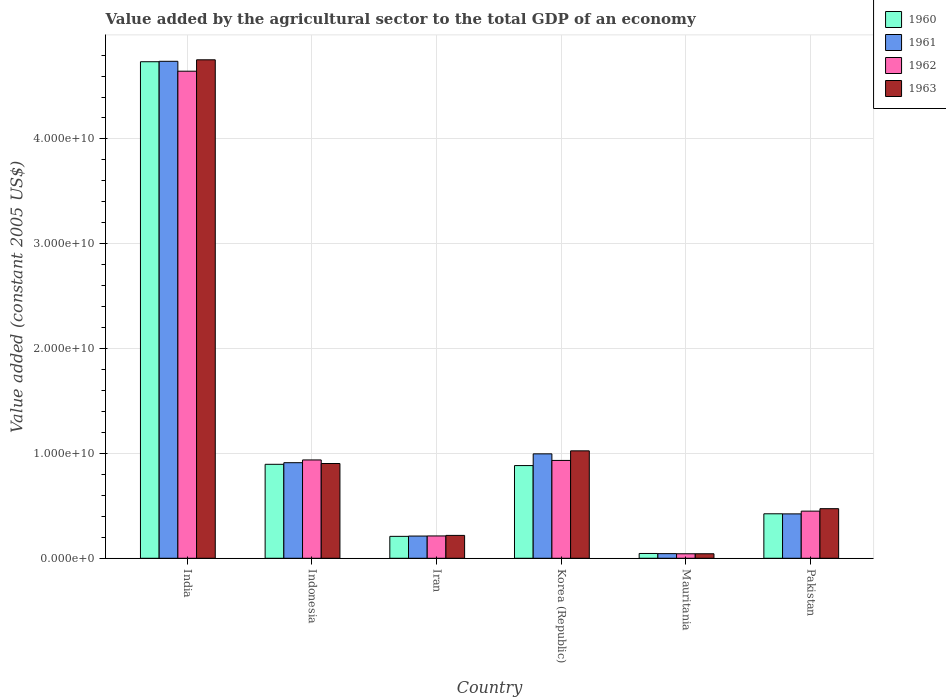Are the number of bars per tick equal to the number of legend labels?
Offer a very short reply. Yes. How many bars are there on the 5th tick from the left?
Give a very brief answer. 4. How many bars are there on the 6th tick from the right?
Make the answer very short. 4. What is the label of the 5th group of bars from the left?
Keep it short and to the point. Mauritania. In how many cases, is the number of bars for a given country not equal to the number of legend labels?
Your answer should be compact. 0. What is the value added by the agricultural sector in 1960 in Indonesia?
Make the answer very short. 8.96e+09. Across all countries, what is the maximum value added by the agricultural sector in 1961?
Give a very brief answer. 4.74e+1. Across all countries, what is the minimum value added by the agricultural sector in 1960?
Provide a succinct answer. 4.57e+08. In which country was the value added by the agricultural sector in 1960 maximum?
Provide a succinct answer. India. In which country was the value added by the agricultural sector in 1962 minimum?
Ensure brevity in your answer.  Mauritania. What is the total value added by the agricultural sector in 1962 in the graph?
Offer a very short reply. 7.22e+1. What is the difference between the value added by the agricultural sector in 1963 in Mauritania and that in Pakistan?
Your answer should be compact. -4.30e+09. What is the difference between the value added by the agricultural sector in 1961 in Pakistan and the value added by the agricultural sector in 1962 in India?
Your answer should be very brief. -4.22e+1. What is the average value added by the agricultural sector in 1963 per country?
Offer a terse response. 1.24e+1. What is the difference between the value added by the agricultural sector of/in 1962 and value added by the agricultural sector of/in 1960 in India?
Offer a very short reply. -9.03e+08. In how many countries, is the value added by the agricultural sector in 1960 greater than 6000000000 US$?
Ensure brevity in your answer.  3. What is the ratio of the value added by the agricultural sector in 1962 in Korea (Republic) to that in Mauritania?
Provide a short and direct response. 21.75. Is the value added by the agricultural sector in 1961 in Indonesia less than that in Pakistan?
Your answer should be compact. No. Is the difference between the value added by the agricultural sector in 1962 in Iran and Pakistan greater than the difference between the value added by the agricultural sector in 1960 in Iran and Pakistan?
Provide a short and direct response. No. What is the difference between the highest and the second highest value added by the agricultural sector in 1962?
Your response must be concise. 3.71e+1. What is the difference between the highest and the lowest value added by the agricultural sector in 1963?
Keep it short and to the point. 4.71e+1. Is the sum of the value added by the agricultural sector in 1962 in Korea (Republic) and Mauritania greater than the maximum value added by the agricultural sector in 1963 across all countries?
Provide a succinct answer. No. What does the 3rd bar from the left in India represents?
Make the answer very short. 1962. What does the 2nd bar from the right in Iran represents?
Make the answer very short. 1962. Are all the bars in the graph horizontal?
Ensure brevity in your answer.  No. How many countries are there in the graph?
Keep it short and to the point. 6. Are the values on the major ticks of Y-axis written in scientific E-notation?
Provide a succinct answer. Yes. How many legend labels are there?
Keep it short and to the point. 4. What is the title of the graph?
Your response must be concise. Value added by the agricultural sector to the total GDP of an economy. Does "1988" appear as one of the legend labels in the graph?
Provide a short and direct response. No. What is the label or title of the Y-axis?
Your answer should be very brief. Value added (constant 2005 US$). What is the Value added (constant 2005 US$) of 1960 in India?
Ensure brevity in your answer.  4.74e+1. What is the Value added (constant 2005 US$) of 1961 in India?
Offer a terse response. 4.74e+1. What is the Value added (constant 2005 US$) of 1962 in India?
Ensure brevity in your answer.  4.65e+1. What is the Value added (constant 2005 US$) of 1963 in India?
Your response must be concise. 4.76e+1. What is the Value added (constant 2005 US$) in 1960 in Indonesia?
Keep it short and to the point. 8.96e+09. What is the Value added (constant 2005 US$) in 1961 in Indonesia?
Your answer should be very brief. 9.12e+09. What is the Value added (constant 2005 US$) of 1962 in Indonesia?
Keep it short and to the point. 9.38e+09. What is the Value added (constant 2005 US$) of 1963 in Indonesia?
Your response must be concise. 9.04e+09. What is the Value added (constant 2005 US$) of 1960 in Iran?
Your response must be concise. 2.09e+09. What is the Value added (constant 2005 US$) of 1961 in Iran?
Provide a short and direct response. 2.12e+09. What is the Value added (constant 2005 US$) of 1962 in Iran?
Provide a succinct answer. 2.13e+09. What is the Value added (constant 2005 US$) of 1963 in Iran?
Your response must be concise. 2.18e+09. What is the Value added (constant 2005 US$) in 1960 in Korea (Republic)?
Your answer should be compact. 8.84e+09. What is the Value added (constant 2005 US$) of 1961 in Korea (Republic)?
Give a very brief answer. 9.96e+09. What is the Value added (constant 2005 US$) in 1962 in Korea (Republic)?
Provide a succinct answer. 9.33e+09. What is the Value added (constant 2005 US$) of 1963 in Korea (Republic)?
Provide a succinct answer. 1.02e+1. What is the Value added (constant 2005 US$) in 1960 in Mauritania?
Your answer should be compact. 4.57e+08. What is the Value added (constant 2005 US$) in 1961 in Mauritania?
Your response must be concise. 4.42e+08. What is the Value added (constant 2005 US$) of 1962 in Mauritania?
Keep it short and to the point. 4.29e+08. What is the Value added (constant 2005 US$) in 1963 in Mauritania?
Make the answer very short. 4.30e+08. What is the Value added (constant 2005 US$) of 1960 in Pakistan?
Offer a very short reply. 4.24e+09. What is the Value added (constant 2005 US$) in 1961 in Pakistan?
Make the answer very short. 4.23e+09. What is the Value added (constant 2005 US$) in 1962 in Pakistan?
Your response must be concise. 4.50e+09. What is the Value added (constant 2005 US$) in 1963 in Pakistan?
Your response must be concise. 4.73e+09. Across all countries, what is the maximum Value added (constant 2005 US$) of 1960?
Give a very brief answer. 4.74e+1. Across all countries, what is the maximum Value added (constant 2005 US$) in 1961?
Your answer should be very brief. 4.74e+1. Across all countries, what is the maximum Value added (constant 2005 US$) in 1962?
Provide a succinct answer. 4.65e+1. Across all countries, what is the maximum Value added (constant 2005 US$) in 1963?
Offer a terse response. 4.76e+1. Across all countries, what is the minimum Value added (constant 2005 US$) in 1960?
Provide a short and direct response. 4.57e+08. Across all countries, what is the minimum Value added (constant 2005 US$) of 1961?
Provide a short and direct response. 4.42e+08. Across all countries, what is the minimum Value added (constant 2005 US$) of 1962?
Ensure brevity in your answer.  4.29e+08. Across all countries, what is the minimum Value added (constant 2005 US$) in 1963?
Give a very brief answer. 4.30e+08. What is the total Value added (constant 2005 US$) of 1960 in the graph?
Ensure brevity in your answer.  7.20e+1. What is the total Value added (constant 2005 US$) in 1961 in the graph?
Offer a very short reply. 7.33e+1. What is the total Value added (constant 2005 US$) in 1962 in the graph?
Your response must be concise. 7.22e+1. What is the total Value added (constant 2005 US$) of 1963 in the graph?
Your response must be concise. 7.42e+1. What is the difference between the Value added (constant 2005 US$) in 1960 in India and that in Indonesia?
Your answer should be compact. 3.84e+1. What is the difference between the Value added (constant 2005 US$) of 1961 in India and that in Indonesia?
Give a very brief answer. 3.83e+1. What is the difference between the Value added (constant 2005 US$) of 1962 in India and that in Indonesia?
Your answer should be compact. 3.71e+1. What is the difference between the Value added (constant 2005 US$) in 1963 in India and that in Indonesia?
Your response must be concise. 3.85e+1. What is the difference between the Value added (constant 2005 US$) of 1960 in India and that in Iran?
Make the answer very short. 4.53e+1. What is the difference between the Value added (constant 2005 US$) of 1961 in India and that in Iran?
Offer a terse response. 4.53e+1. What is the difference between the Value added (constant 2005 US$) in 1962 in India and that in Iran?
Provide a succinct answer. 4.43e+1. What is the difference between the Value added (constant 2005 US$) in 1963 in India and that in Iran?
Your answer should be compact. 4.54e+1. What is the difference between the Value added (constant 2005 US$) of 1960 in India and that in Korea (Republic)?
Provide a short and direct response. 3.85e+1. What is the difference between the Value added (constant 2005 US$) in 1961 in India and that in Korea (Republic)?
Your response must be concise. 3.74e+1. What is the difference between the Value added (constant 2005 US$) in 1962 in India and that in Korea (Republic)?
Offer a terse response. 3.71e+1. What is the difference between the Value added (constant 2005 US$) of 1963 in India and that in Korea (Republic)?
Offer a terse response. 3.73e+1. What is the difference between the Value added (constant 2005 US$) of 1960 in India and that in Mauritania?
Offer a very short reply. 4.69e+1. What is the difference between the Value added (constant 2005 US$) in 1961 in India and that in Mauritania?
Give a very brief answer. 4.70e+1. What is the difference between the Value added (constant 2005 US$) of 1962 in India and that in Mauritania?
Your response must be concise. 4.60e+1. What is the difference between the Value added (constant 2005 US$) of 1963 in India and that in Mauritania?
Keep it short and to the point. 4.71e+1. What is the difference between the Value added (constant 2005 US$) of 1960 in India and that in Pakistan?
Provide a short and direct response. 4.31e+1. What is the difference between the Value added (constant 2005 US$) in 1961 in India and that in Pakistan?
Your answer should be compact. 4.32e+1. What is the difference between the Value added (constant 2005 US$) of 1962 in India and that in Pakistan?
Your response must be concise. 4.20e+1. What is the difference between the Value added (constant 2005 US$) of 1963 in India and that in Pakistan?
Provide a short and direct response. 4.28e+1. What is the difference between the Value added (constant 2005 US$) in 1960 in Indonesia and that in Iran?
Your answer should be very brief. 6.87e+09. What is the difference between the Value added (constant 2005 US$) in 1961 in Indonesia and that in Iran?
Offer a very short reply. 7.00e+09. What is the difference between the Value added (constant 2005 US$) of 1962 in Indonesia and that in Iran?
Give a very brief answer. 7.25e+09. What is the difference between the Value added (constant 2005 US$) in 1963 in Indonesia and that in Iran?
Make the answer very short. 6.86e+09. What is the difference between the Value added (constant 2005 US$) of 1960 in Indonesia and that in Korea (Republic)?
Make the answer very short. 1.19e+08. What is the difference between the Value added (constant 2005 US$) of 1961 in Indonesia and that in Korea (Republic)?
Provide a succinct answer. -8.44e+08. What is the difference between the Value added (constant 2005 US$) of 1962 in Indonesia and that in Korea (Republic)?
Provide a short and direct response. 4.52e+07. What is the difference between the Value added (constant 2005 US$) of 1963 in Indonesia and that in Korea (Republic)?
Your answer should be compact. -1.21e+09. What is the difference between the Value added (constant 2005 US$) of 1960 in Indonesia and that in Mauritania?
Ensure brevity in your answer.  8.51e+09. What is the difference between the Value added (constant 2005 US$) in 1961 in Indonesia and that in Mauritania?
Your response must be concise. 8.68e+09. What is the difference between the Value added (constant 2005 US$) of 1962 in Indonesia and that in Mauritania?
Your answer should be compact. 8.95e+09. What is the difference between the Value added (constant 2005 US$) in 1963 in Indonesia and that in Mauritania?
Ensure brevity in your answer.  8.61e+09. What is the difference between the Value added (constant 2005 US$) of 1960 in Indonesia and that in Pakistan?
Your answer should be very brief. 4.72e+09. What is the difference between the Value added (constant 2005 US$) of 1961 in Indonesia and that in Pakistan?
Provide a short and direct response. 4.88e+09. What is the difference between the Value added (constant 2005 US$) of 1962 in Indonesia and that in Pakistan?
Make the answer very short. 4.88e+09. What is the difference between the Value added (constant 2005 US$) in 1963 in Indonesia and that in Pakistan?
Offer a very short reply. 4.31e+09. What is the difference between the Value added (constant 2005 US$) of 1960 in Iran and that in Korea (Republic)?
Offer a terse response. -6.75e+09. What is the difference between the Value added (constant 2005 US$) in 1961 in Iran and that in Korea (Republic)?
Provide a succinct answer. -7.84e+09. What is the difference between the Value added (constant 2005 US$) in 1962 in Iran and that in Korea (Republic)?
Ensure brevity in your answer.  -7.20e+09. What is the difference between the Value added (constant 2005 US$) in 1963 in Iran and that in Korea (Republic)?
Offer a very short reply. -8.07e+09. What is the difference between the Value added (constant 2005 US$) in 1960 in Iran and that in Mauritania?
Provide a succinct answer. 1.63e+09. What is the difference between the Value added (constant 2005 US$) in 1961 in Iran and that in Mauritania?
Provide a short and direct response. 1.68e+09. What is the difference between the Value added (constant 2005 US$) in 1962 in Iran and that in Mauritania?
Keep it short and to the point. 1.70e+09. What is the difference between the Value added (constant 2005 US$) of 1963 in Iran and that in Mauritania?
Your answer should be very brief. 1.75e+09. What is the difference between the Value added (constant 2005 US$) in 1960 in Iran and that in Pakistan?
Offer a very short reply. -2.15e+09. What is the difference between the Value added (constant 2005 US$) in 1961 in Iran and that in Pakistan?
Ensure brevity in your answer.  -2.11e+09. What is the difference between the Value added (constant 2005 US$) in 1962 in Iran and that in Pakistan?
Your answer should be compact. -2.37e+09. What is the difference between the Value added (constant 2005 US$) of 1963 in Iran and that in Pakistan?
Give a very brief answer. -2.55e+09. What is the difference between the Value added (constant 2005 US$) of 1960 in Korea (Republic) and that in Mauritania?
Provide a succinct answer. 8.39e+09. What is the difference between the Value added (constant 2005 US$) in 1961 in Korea (Republic) and that in Mauritania?
Give a very brief answer. 9.52e+09. What is the difference between the Value added (constant 2005 US$) in 1962 in Korea (Republic) and that in Mauritania?
Your response must be concise. 8.91e+09. What is the difference between the Value added (constant 2005 US$) in 1963 in Korea (Republic) and that in Mauritania?
Keep it short and to the point. 9.82e+09. What is the difference between the Value added (constant 2005 US$) of 1960 in Korea (Republic) and that in Pakistan?
Offer a very short reply. 4.60e+09. What is the difference between the Value added (constant 2005 US$) of 1961 in Korea (Republic) and that in Pakistan?
Your answer should be compact. 5.73e+09. What is the difference between the Value added (constant 2005 US$) of 1962 in Korea (Republic) and that in Pakistan?
Your answer should be very brief. 4.84e+09. What is the difference between the Value added (constant 2005 US$) of 1963 in Korea (Republic) and that in Pakistan?
Provide a succinct answer. 5.52e+09. What is the difference between the Value added (constant 2005 US$) in 1960 in Mauritania and that in Pakistan?
Offer a very short reply. -3.79e+09. What is the difference between the Value added (constant 2005 US$) of 1961 in Mauritania and that in Pakistan?
Your answer should be very brief. -3.79e+09. What is the difference between the Value added (constant 2005 US$) of 1962 in Mauritania and that in Pakistan?
Make the answer very short. -4.07e+09. What is the difference between the Value added (constant 2005 US$) in 1963 in Mauritania and that in Pakistan?
Offer a terse response. -4.30e+09. What is the difference between the Value added (constant 2005 US$) of 1960 in India and the Value added (constant 2005 US$) of 1961 in Indonesia?
Give a very brief answer. 3.83e+1. What is the difference between the Value added (constant 2005 US$) in 1960 in India and the Value added (constant 2005 US$) in 1962 in Indonesia?
Provide a short and direct response. 3.80e+1. What is the difference between the Value added (constant 2005 US$) of 1960 in India and the Value added (constant 2005 US$) of 1963 in Indonesia?
Your answer should be compact. 3.83e+1. What is the difference between the Value added (constant 2005 US$) in 1961 in India and the Value added (constant 2005 US$) in 1962 in Indonesia?
Offer a terse response. 3.80e+1. What is the difference between the Value added (constant 2005 US$) in 1961 in India and the Value added (constant 2005 US$) in 1963 in Indonesia?
Your answer should be compact. 3.84e+1. What is the difference between the Value added (constant 2005 US$) of 1962 in India and the Value added (constant 2005 US$) of 1963 in Indonesia?
Give a very brief answer. 3.74e+1. What is the difference between the Value added (constant 2005 US$) in 1960 in India and the Value added (constant 2005 US$) in 1961 in Iran?
Provide a short and direct response. 4.52e+1. What is the difference between the Value added (constant 2005 US$) in 1960 in India and the Value added (constant 2005 US$) in 1962 in Iran?
Provide a succinct answer. 4.52e+1. What is the difference between the Value added (constant 2005 US$) in 1960 in India and the Value added (constant 2005 US$) in 1963 in Iran?
Your response must be concise. 4.52e+1. What is the difference between the Value added (constant 2005 US$) of 1961 in India and the Value added (constant 2005 US$) of 1962 in Iran?
Offer a very short reply. 4.53e+1. What is the difference between the Value added (constant 2005 US$) of 1961 in India and the Value added (constant 2005 US$) of 1963 in Iran?
Give a very brief answer. 4.52e+1. What is the difference between the Value added (constant 2005 US$) of 1962 in India and the Value added (constant 2005 US$) of 1963 in Iran?
Offer a terse response. 4.43e+1. What is the difference between the Value added (constant 2005 US$) in 1960 in India and the Value added (constant 2005 US$) in 1961 in Korea (Republic)?
Provide a short and direct response. 3.74e+1. What is the difference between the Value added (constant 2005 US$) of 1960 in India and the Value added (constant 2005 US$) of 1962 in Korea (Republic)?
Your answer should be compact. 3.80e+1. What is the difference between the Value added (constant 2005 US$) in 1960 in India and the Value added (constant 2005 US$) in 1963 in Korea (Republic)?
Give a very brief answer. 3.71e+1. What is the difference between the Value added (constant 2005 US$) of 1961 in India and the Value added (constant 2005 US$) of 1962 in Korea (Republic)?
Provide a short and direct response. 3.81e+1. What is the difference between the Value added (constant 2005 US$) of 1961 in India and the Value added (constant 2005 US$) of 1963 in Korea (Republic)?
Offer a terse response. 3.72e+1. What is the difference between the Value added (constant 2005 US$) in 1962 in India and the Value added (constant 2005 US$) in 1963 in Korea (Republic)?
Keep it short and to the point. 3.62e+1. What is the difference between the Value added (constant 2005 US$) in 1960 in India and the Value added (constant 2005 US$) in 1961 in Mauritania?
Offer a very short reply. 4.69e+1. What is the difference between the Value added (constant 2005 US$) of 1960 in India and the Value added (constant 2005 US$) of 1962 in Mauritania?
Your answer should be very brief. 4.69e+1. What is the difference between the Value added (constant 2005 US$) of 1960 in India and the Value added (constant 2005 US$) of 1963 in Mauritania?
Your answer should be very brief. 4.69e+1. What is the difference between the Value added (constant 2005 US$) in 1961 in India and the Value added (constant 2005 US$) in 1962 in Mauritania?
Offer a very short reply. 4.70e+1. What is the difference between the Value added (constant 2005 US$) of 1961 in India and the Value added (constant 2005 US$) of 1963 in Mauritania?
Provide a short and direct response. 4.70e+1. What is the difference between the Value added (constant 2005 US$) of 1962 in India and the Value added (constant 2005 US$) of 1963 in Mauritania?
Offer a very short reply. 4.60e+1. What is the difference between the Value added (constant 2005 US$) of 1960 in India and the Value added (constant 2005 US$) of 1961 in Pakistan?
Your answer should be very brief. 4.31e+1. What is the difference between the Value added (constant 2005 US$) in 1960 in India and the Value added (constant 2005 US$) in 1962 in Pakistan?
Ensure brevity in your answer.  4.29e+1. What is the difference between the Value added (constant 2005 US$) of 1960 in India and the Value added (constant 2005 US$) of 1963 in Pakistan?
Offer a very short reply. 4.26e+1. What is the difference between the Value added (constant 2005 US$) of 1961 in India and the Value added (constant 2005 US$) of 1962 in Pakistan?
Offer a very short reply. 4.29e+1. What is the difference between the Value added (constant 2005 US$) in 1961 in India and the Value added (constant 2005 US$) in 1963 in Pakistan?
Offer a very short reply. 4.27e+1. What is the difference between the Value added (constant 2005 US$) in 1962 in India and the Value added (constant 2005 US$) in 1963 in Pakistan?
Your response must be concise. 4.17e+1. What is the difference between the Value added (constant 2005 US$) in 1960 in Indonesia and the Value added (constant 2005 US$) in 1961 in Iran?
Keep it short and to the point. 6.84e+09. What is the difference between the Value added (constant 2005 US$) of 1960 in Indonesia and the Value added (constant 2005 US$) of 1962 in Iran?
Your answer should be compact. 6.83e+09. What is the difference between the Value added (constant 2005 US$) of 1960 in Indonesia and the Value added (constant 2005 US$) of 1963 in Iran?
Ensure brevity in your answer.  6.78e+09. What is the difference between the Value added (constant 2005 US$) in 1961 in Indonesia and the Value added (constant 2005 US$) in 1962 in Iran?
Give a very brief answer. 6.99e+09. What is the difference between the Value added (constant 2005 US$) of 1961 in Indonesia and the Value added (constant 2005 US$) of 1963 in Iran?
Provide a succinct answer. 6.94e+09. What is the difference between the Value added (constant 2005 US$) of 1962 in Indonesia and the Value added (constant 2005 US$) of 1963 in Iran?
Provide a short and direct response. 7.20e+09. What is the difference between the Value added (constant 2005 US$) of 1960 in Indonesia and the Value added (constant 2005 US$) of 1961 in Korea (Republic)?
Your answer should be very brief. -9.98e+08. What is the difference between the Value added (constant 2005 US$) of 1960 in Indonesia and the Value added (constant 2005 US$) of 1962 in Korea (Republic)?
Give a very brief answer. -3.71e+08. What is the difference between the Value added (constant 2005 US$) in 1960 in Indonesia and the Value added (constant 2005 US$) in 1963 in Korea (Republic)?
Provide a short and direct response. -1.28e+09. What is the difference between the Value added (constant 2005 US$) in 1961 in Indonesia and the Value added (constant 2005 US$) in 1962 in Korea (Republic)?
Ensure brevity in your answer.  -2.17e+08. What is the difference between the Value added (constant 2005 US$) in 1961 in Indonesia and the Value added (constant 2005 US$) in 1963 in Korea (Republic)?
Ensure brevity in your answer.  -1.13e+09. What is the difference between the Value added (constant 2005 US$) of 1962 in Indonesia and the Value added (constant 2005 US$) of 1963 in Korea (Republic)?
Provide a short and direct response. -8.69e+08. What is the difference between the Value added (constant 2005 US$) of 1960 in Indonesia and the Value added (constant 2005 US$) of 1961 in Mauritania?
Make the answer very short. 8.52e+09. What is the difference between the Value added (constant 2005 US$) of 1960 in Indonesia and the Value added (constant 2005 US$) of 1962 in Mauritania?
Give a very brief answer. 8.53e+09. What is the difference between the Value added (constant 2005 US$) of 1960 in Indonesia and the Value added (constant 2005 US$) of 1963 in Mauritania?
Your response must be concise. 8.53e+09. What is the difference between the Value added (constant 2005 US$) in 1961 in Indonesia and the Value added (constant 2005 US$) in 1962 in Mauritania?
Give a very brief answer. 8.69e+09. What is the difference between the Value added (constant 2005 US$) of 1961 in Indonesia and the Value added (constant 2005 US$) of 1963 in Mauritania?
Offer a very short reply. 8.69e+09. What is the difference between the Value added (constant 2005 US$) of 1962 in Indonesia and the Value added (constant 2005 US$) of 1963 in Mauritania?
Your answer should be very brief. 8.95e+09. What is the difference between the Value added (constant 2005 US$) in 1960 in Indonesia and the Value added (constant 2005 US$) in 1961 in Pakistan?
Your answer should be very brief. 4.73e+09. What is the difference between the Value added (constant 2005 US$) in 1960 in Indonesia and the Value added (constant 2005 US$) in 1962 in Pakistan?
Make the answer very short. 4.47e+09. What is the difference between the Value added (constant 2005 US$) of 1960 in Indonesia and the Value added (constant 2005 US$) of 1963 in Pakistan?
Make the answer very short. 4.23e+09. What is the difference between the Value added (constant 2005 US$) of 1961 in Indonesia and the Value added (constant 2005 US$) of 1962 in Pakistan?
Your response must be concise. 4.62e+09. What is the difference between the Value added (constant 2005 US$) in 1961 in Indonesia and the Value added (constant 2005 US$) in 1963 in Pakistan?
Provide a short and direct response. 4.39e+09. What is the difference between the Value added (constant 2005 US$) in 1962 in Indonesia and the Value added (constant 2005 US$) in 1963 in Pakistan?
Your answer should be very brief. 4.65e+09. What is the difference between the Value added (constant 2005 US$) in 1960 in Iran and the Value added (constant 2005 US$) in 1961 in Korea (Republic)?
Your answer should be compact. -7.87e+09. What is the difference between the Value added (constant 2005 US$) of 1960 in Iran and the Value added (constant 2005 US$) of 1962 in Korea (Republic)?
Offer a very short reply. -7.24e+09. What is the difference between the Value added (constant 2005 US$) of 1960 in Iran and the Value added (constant 2005 US$) of 1963 in Korea (Republic)?
Your answer should be very brief. -8.16e+09. What is the difference between the Value added (constant 2005 US$) in 1961 in Iran and the Value added (constant 2005 US$) in 1962 in Korea (Republic)?
Offer a terse response. -7.21e+09. What is the difference between the Value added (constant 2005 US$) in 1961 in Iran and the Value added (constant 2005 US$) in 1963 in Korea (Republic)?
Ensure brevity in your answer.  -8.13e+09. What is the difference between the Value added (constant 2005 US$) of 1962 in Iran and the Value added (constant 2005 US$) of 1963 in Korea (Republic)?
Provide a succinct answer. -8.12e+09. What is the difference between the Value added (constant 2005 US$) in 1960 in Iran and the Value added (constant 2005 US$) in 1961 in Mauritania?
Your response must be concise. 1.65e+09. What is the difference between the Value added (constant 2005 US$) of 1960 in Iran and the Value added (constant 2005 US$) of 1962 in Mauritania?
Provide a short and direct response. 1.66e+09. What is the difference between the Value added (constant 2005 US$) of 1960 in Iran and the Value added (constant 2005 US$) of 1963 in Mauritania?
Your response must be concise. 1.66e+09. What is the difference between the Value added (constant 2005 US$) of 1961 in Iran and the Value added (constant 2005 US$) of 1962 in Mauritania?
Make the answer very short. 1.69e+09. What is the difference between the Value added (constant 2005 US$) of 1961 in Iran and the Value added (constant 2005 US$) of 1963 in Mauritania?
Your response must be concise. 1.69e+09. What is the difference between the Value added (constant 2005 US$) in 1962 in Iran and the Value added (constant 2005 US$) in 1963 in Mauritania?
Provide a succinct answer. 1.70e+09. What is the difference between the Value added (constant 2005 US$) in 1960 in Iran and the Value added (constant 2005 US$) in 1961 in Pakistan?
Ensure brevity in your answer.  -2.14e+09. What is the difference between the Value added (constant 2005 US$) in 1960 in Iran and the Value added (constant 2005 US$) in 1962 in Pakistan?
Your answer should be compact. -2.40e+09. What is the difference between the Value added (constant 2005 US$) in 1960 in Iran and the Value added (constant 2005 US$) in 1963 in Pakistan?
Provide a succinct answer. -2.64e+09. What is the difference between the Value added (constant 2005 US$) of 1961 in Iran and the Value added (constant 2005 US$) of 1962 in Pakistan?
Keep it short and to the point. -2.38e+09. What is the difference between the Value added (constant 2005 US$) of 1961 in Iran and the Value added (constant 2005 US$) of 1963 in Pakistan?
Keep it short and to the point. -2.61e+09. What is the difference between the Value added (constant 2005 US$) in 1962 in Iran and the Value added (constant 2005 US$) in 1963 in Pakistan?
Your answer should be very brief. -2.60e+09. What is the difference between the Value added (constant 2005 US$) of 1960 in Korea (Republic) and the Value added (constant 2005 US$) of 1961 in Mauritania?
Ensure brevity in your answer.  8.40e+09. What is the difference between the Value added (constant 2005 US$) in 1960 in Korea (Republic) and the Value added (constant 2005 US$) in 1962 in Mauritania?
Your answer should be very brief. 8.41e+09. What is the difference between the Value added (constant 2005 US$) of 1960 in Korea (Republic) and the Value added (constant 2005 US$) of 1963 in Mauritania?
Your answer should be compact. 8.41e+09. What is the difference between the Value added (constant 2005 US$) in 1961 in Korea (Republic) and the Value added (constant 2005 US$) in 1962 in Mauritania?
Provide a succinct answer. 9.53e+09. What is the difference between the Value added (constant 2005 US$) of 1961 in Korea (Republic) and the Value added (constant 2005 US$) of 1963 in Mauritania?
Offer a very short reply. 9.53e+09. What is the difference between the Value added (constant 2005 US$) in 1962 in Korea (Republic) and the Value added (constant 2005 US$) in 1963 in Mauritania?
Offer a terse response. 8.90e+09. What is the difference between the Value added (constant 2005 US$) in 1960 in Korea (Republic) and the Value added (constant 2005 US$) in 1961 in Pakistan?
Give a very brief answer. 4.61e+09. What is the difference between the Value added (constant 2005 US$) in 1960 in Korea (Republic) and the Value added (constant 2005 US$) in 1962 in Pakistan?
Keep it short and to the point. 4.35e+09. What is the difference between the Value added (constant 2005 US$) in 1960 in Korea (Republic) and the Value added (constant 2005 US$) in 1963 in Pakistan?
Your response must be concise. 4.11e+09. What is the difference between the Value added (constant 2005 US$) in 1961 in Korea (Republic) and the Value added (constant 2005 US$) in 1962 in Pakistan?
Your response must be concise. 5.46e+09. What is the difference between the Value added (constant 2005 US$) of 1961 in Korea (Republic) and the Value added (constant 2005 US$) of 1963 in Pakistan?
Keep it short and to the point. 5.23e+09. What is the difference between the Value added (constant 2005 US$) in 1962 in Korea (Republic) and the Value added (constant 2005 US$) in 1963 in Pakistan?
Provide a succinct answer. 4.60e+09. What is the difference between the Value added (constant 2005 US$) of 1960 in Mauritania and the Value added (constant 2005 US$) of 1961 in Pakistan?
Your answer should be very brief. -3.78e+09. What is the difference between the Value added (constant 2005 US$) in 1960 in Mauritania and the Value added (constant 2005 US$) in 1962 in Pakistan?
Provide a short and direct response. -4.04e+09. What is the difference between the Value added (constant 2005 US$) in 1960 in Mauritania and the Value added (constant 2005 US$) in 1963 in Pakistan?
Ensure brevity in your answer.  -4.27e+09. What is the difference between the Value added (constant 2005 US$) in 1961 in Mauritania and the Value added (constant 2005 US$) in 1962 in Pakistan?
Ensure brevity in your answer.  -4.05e+09. What is the difference between the Value added (constant 2005 US$) of 1961 in Mauritania and the Value added (constant 2005 US$) of 1963 in Pakistan?
Your answer should be compact. -4.29e+09. What is the difference between the Value added (constant 2005 US$) of 1962 in Mauritania and the Value added (constant 2005 US$) of 1963 in Pakistan?
Make the answer very short. -4.30e+09. What is the average Value added (constant 2005 US$) in 1960 per country?
Give a very brief answer. 1.20e+1. What is the average Value added (constant 2005 US$) of 1961 per country?
Your answer should be compact. 1.22e+1. What is the average Value added (constant 2005 US$) of 1962 per country?
Your answer should be very brief. 1.20e+1. What is the average Value added (constant 2005 US$) in 1963 per country?
Provide a succinct answer. 1.24e+1. What is the difference between the Value added (constant 2005 US$) in 1960 and Value added (constant 2005 US$) in 1961 in India?
Provide a succinct answer. -3.99e+07. What is the difference between the Value added (constant 2005 US$) in 1960 and Value added (constant 2005 US$) in 1962 in India?
Provide a short and direct response. 9.03e+08. What is the difference between the Value added (constant 2005 US$) in 1960 and Value added (constant 2005 US$) in 1963 in India?
Give a very brief answer. -1.84e+08. What is the difference between the Value added (constant 2005 US$) of 1961 and Value added (constant 2005 US$) of 1962 in India?
Provide a succinct answer. 9.43e+08. What is the difference between the Value added (constant 2005 US$) of 1961 and Value added (constant 2005 US$) of 1963 in India?
Your response must be concise. -1.44e+08. What is the difference between the Value added (constant 2005 US$) of 1962 and Value added (constant 2005 US$) of 1963 in India?
Keep it short and to the point. -1.09e+09. What is the difference between the Value added (constant 2005 US$) in 1960 and Value added (constant 2005 US$) in 1961 in Indonesia?
Your answer should be compact. -1.54e+08. What is the difference between the Value added (constant 2005 US$) of 1960 and Value added (constant 2005 US$) of 1962 in Indonesia?
Ensure brevity in your answer.  -4.16e+08. What is the difference between the Value added (constant 2005 US$) of 1960 and Value added (constant 2005 US$) of 1963 in Indonesia?
Your answer should be very brief. -7.71e+07. What is the difference between the Value added (constant 2005 US$) in 1961 and Value added (constant 2005 US$) in 1962 in Indonesia?
Your answer should be very brief. -2.62e+08. What is the difference between the Value added (constant 2005 US$) of 1961 and Value added (constant 2005 US$) of 1963 in Indonesia?
Make the answer very short. 7.71e+07. What is the difference between the Value added (constant 2005 US$) in 1962 and Value added (constant 2005 US$) in 1963 in Indonesia?
Your answer should be compact. 3.39e+08. What is the difference between the Value added (constant 2005 US$) of 1960 and Value added (constant 2005 US$) of 1961 in Iran?
Keep it short and to the point. -2.84e+07. What is the difference between the Value added (constant 2005 US$) in 1960 and Value added (constant 2005 US$) in 1962 in Iran?
Keep it short and to the point. -3.89e+07. What is the difference between the Value added (constant 2005 US$) of 1960 and Value added (constant 2005 US$) of 1963 in Iran?
Offer a very short reply. -9.02e+07. What is the difference between the Value added (constant 2005 US$) in 1961 and Value added (constant 2005 US$) in 1962 in Iran?
Keep it short and to the point. -1.05e+07. What is the difference between the Value added (constant 2005 US$) of 1961 and Value added (constant 2005 US$) of 1963 in Iran?
Ensure brevity in your answer.  -6.18e+07. What is the difference between the Value added (constant 2005 US$) of 1962 and Value added (constant 2005 US$) of 1963 in Iran?
Offer a terse response. -5.13e+07. What is the difference between the Value added (constant 2005 US$) in 1960 and Value added (constant 2005 US$) in 1961 in Korea (Republic)?
Ensure brevity in your answer.  -1.12e+09. What is the difference between the Value added (constant 2005 US$) in 1960 and Value added (constant 2005 US$) in 1962 in Korea (Republic)?
Your answer should be very brief. -4.90e+08. What is the difference between the Value added (constant 2005 US$) in 1960 and Value added (constant 2005 US$) in 1963 in Korea (Republic)?
Your answer should be compact. -1.40e+09. What is the difference between the Value added (constant 2005 US$) in 1961 and Value added (constant 2005 US$) in 1962 in Korea (Republic)?
Make the answer very short. 6.27e+08. What is the difference between the Value added (constant 2005 US$) in 1961 and Value added (constant 2005 US$) in 1963 in Korea (Republic)?
Offer a terse response. -2.87e+08. What is the difference between the Value added (constant 2005 US$) of 1962 and Value added (constant 2005 US$) of 1963 in Korea (Republic)?
Ensure brevity in your answer.  -9.14e+08. What is the difference between the Value added (constant 2005 US$) in 1960 and Value added (constant 2005 US$) in 1961 in Mauritania?
Give a very brief answer. 1.44e+07. What is the difference between the Value added (constant 2005 US$) in 1960 and Value added (constant 2005 US$) in 1962 in Mauritania?
Give a very brief answer. 2.75e+07. What is the difference between the Value added (constant 2005 US$) of 1960 and Value added (constant 2005 US$) of 1963 in Mauritania?
Your response must be concise. 2.68e+07. What is the difference between the Value added (constant 2005 US$) in 1961 and Value added (constant 2005 US$) in 1962 in Mauritania?
Ensure brevity in your answer.  1.31e+07. What is the difference between the Value added (constant 2005 US$) in 1961 and Value added (constant 2005 US$) in 1963 in Mauritania?
Give a very brief answer. 1.24e+07. What is the difference between the Value added (constant 2005 US$) of 1962 and Value added (constant 2005 US$) of 1963 in Mauritania?
Provide a succinct answer. -7.06e+05. What is the difference between the Value added (constant 2005 US$) of 1960 and Value added (constant 2005 US$) of 1961 in Pakistan?
Ensure brevity in your answer.  8.56e+06. What is the difference between the Value added (constant 2005 US$) in 1960 and Value added (constant 2005 US$) in 1962 in Pakistan?
Keep it short and to the point. -2.53e+08. What is the difference between the Value added (constant 2005 US$) of 1960 and Value added (constant 2005 US$) of 1963 in Pakistan?
Ensure brevity in your answer.  -4.87e+08. What is the difference between the Value added (constant 2005 US$) of 1961 and Value added (constant 2005 US$) of 1962 in Pakistan?
Your answer should be compact. -2.62e+08. What is the difference between the Value added (constant 2005 US$) in 1961 and Value added (constant 2005 US$) in 1963 in Pakistan?
Make the answer very short. -4.96e+08. What is the difference between the Value added (constant 2005 US$) in 1962 and Value added (constant 2005 US$) in 1963 in Pakistan?
Your answer should be compact. -2.34e+08. What is the ratio of the Value added (constant 2005 US$) in 1960 in India to that in Indonesia?
Keep it short and to the point. 5.28. What is the ratio of the Value added (constant 2005 US$) of 1961 in India to that in Indonesia?
Offer a very short reply. 5.2. What is the ratio of the Value added (constant 2005 US$) of 1962 in India to that in Indonesia?
Make the answer very short. 4.95. What is the ratio of the Value added (constant 2005 US$) in 1963 in India to that in Indonesia?
Your response must be concise. 5.26. What is the ratio of the Value added (constant 2005 US$) in 1960 in India to that in Iran?
Provide a short and direct response. 22.65. What is the ratio of the Value added (constant 2005 US$) in 1961 in India to that in Iran?
Your answer should be very brief. 22.37. What is the ratio of the Value added (constant 2005 US$) in 1962 in India to that in Iran?
Provide a succinct answer. 21.81. What is the ratio of the Value added (constant 2005 US$) in 1963 in India to that in Iran?
Your answer should be compact. 21.8. What is the ratio of the Value added (constant 2005 US$) in 1960 in India to that in Korea (Republic)?
Offer a very short reply. 5.36. What is the ratio of the Value added (constant 2005 US$) in 1961 in India to that in Korea (Republic)?
Make the answer very short. 4.76. What is the ratio of the Value added (constant 2005 US$) of 1962 in India to that in Korea (Republic)?
Ensure brevity in your answer.  4.98. What is the ratio of the Value added (constant 2005 US$) in 1963 in India to that in Korea (Republic)?
Offer a terse response. 4.64. What is the ratio of the Value added (constant 2005 US$) in 1960 in India to that in Mauritania?
Keep it short and to the point. 103.72. What is the ratio of the Value added (constant 2005 US$) of 1961 in India to that in Mauritania?
Offer a terse response. 107.19. What is the ratio of the Value added (constant 2005 US$) of 1962 in India to that in Mauritania?
Offer a very short reply. 108.27. What is the ratio of the Value added (constant 2005 US$) of 1963 in India to that in Mauritania?
Give a very brief answer. 110.62. What is the ratio of the Value added (constant 2005 US$) of 1960 in India to that in Pakistan?
Your answer should be compact. 11.16. What is the ratio of the Value added (constant 2005 US$) of 1961 in India to that in Pakistan?
Keep it short and to the point. 11.2. What is the ratio of the Value added (constant 2005 US$) in 1962 in India to that in Pakistan?
Ensure brevity in your answer.  10.33. What is the ratio of the Value added (constant 2005 US$) of 1963 in India to that in Pakistan?
Keep it short and to the point. 10.05. What is the ratio of the Value added (constant 2005 US$) in 1960 in Indonesia to that in Iran?
Provide a short and direct response. 4.29. What is the ratio of the Value added (constant 2005 US$) in 1961 in Indonesia to that in Iran?
Ensure brevity in your answer.  4.3. What is the ratio of the Value added (constant 2005 US$) in 1962 in Indonesia to that in Iran?
Offer a terse response. 4.4. What is the ratio of the Value added (constant 2005 US$) of 1963 in Indonesia to that in Iran?
Offer a terse response. 4.14. What is the ratio of the Value added (constant 2005 US$) in 1960 in Indonesia to that in Korea (Republic)?
Your response must be concise. 1.01. What is the ratio of the Value added (constant 2005 US$) of 1961 in Indonesia to that in Korea (Republic)?
Your response must be concise. 0.92. What is the ratio of the Value added (constant 2005 US$) of 1962 in Indonesia to that in Korea (Republic)?
Your answer should be very brief. 1. What is the ratio of the Value added (constant 2005 US$) in 1963 in Indonesia to that in Korea (Republic)?
Make the answer very short. 0.88. What is the ratio of the Value added (constant 2005 US$) in 1960 in Indonesia to that in Mauritania?
Give a very brief answer. 19.63. What is the ratio of the Value added (constant 2005 US$) in 1961 in Indonesia to that in Mauritania?
Ensure brevity in your answer.  20.62. What is the ratio of the Value added (constant 2005 US$) in 1962 in Indonesia to that in Mauritania?
Your response must be concise. 21.86. What is the ratio of the Value added (constant 2005 US$) of 1963 in Indonesia to that in Mauritania?
Provide a short and direct response. 21.03. What is the ratio of the Value added (constant 2005 US$) of 1960 in Indonesia to that in Pakistan?
Provide a short and direct response. 2.11. What is the ratio of the Value added (constant 2005 US$) in 1961 in Indonesia to that in Pakistan?
Provide a short and direct response. 2.15. What is the ratio of the Value added (constant 2005 US$) of 1962 in Indonesia to that in Pakistan?
Give a very brief answer. 2.09. What is the ratio of the Value added (constant 2005 US$) of 1963 in Indonesia to that in Pakistan?
Provide a succinct answer. 1.91. What is the ratio of the Value added (constant 2005 US$) of 1960 in Iran to that in Korea (Republic)?
Provide a succinct answer. 0.24. What is the ratio of the Value added (constant 2005 US$) in 1961 in Iran to that in Korea (Republic)?
Your answer should be very brief. 0.21. What is the ratio of the Value added (constant 2005 US$) of 1962 in Iran to that in Korea (Republic)?
Give a very brief answer. 0.23. What is the ratio of the Value added (constant 2005 US$) in 1963 in Iran to that in Korea (Republic)?
Your answer should be very brief. 0.21. What is the ratio of the Value added (constant 2005 US$) in 1960 in Iran to that in Mauritania?
Provide a short and direct response. 4.58. What is the ratio of the Value added (constant 2005 US$) in 1961 in Iran to that in Mauritania?
Offer a terse response. 4.79. What is the ratio of the Value added (constant 2005 US$) of 1962 in Iran to that in Mauritania?
Your answer should be very brief. 4.96. What is the ratio of the Value added (constant 2005 US$) in 1963 in Iran to that in Mauritania?
Your response must be concise. 5.07. What is the ratio of the Value added (constant 2005 US$) in 1960 in Iran to that in Pakistan?
Provide a short and direct response. 0.49. What is the ratio of the Value added (constant 2005 US$) in 1961 in Iran to that in Pakistan?
Your answer should be compact. 0.5. What is the ratio of the Value added (constant 2005 US$) of 1962 in Iran to that in Pakistan?
Your response must be concise. 0.47. What is the ratio of the Value added (constant 2005 US$) in 1963 in Iran to that in Pakistan?
Keep it short and to the point. 0.46. What is the ratio of the Value added (constant 2005 US$) in 1960 in Korea (Republic) to that in Mauritania?
Provide a short and direct response. 19.37. What is the ratio of the Value added (constant 2005 US$) of 1961 in Korea (Republic) to that in Mauritania?
Offer a very short reply. 22.52. What is the ratio of the Value added (constant 2005 US$) of 1962 in Korea (Republic) to that in Mauritania?
Provide a short and direct response. 21.75. What is the ratio of the Value added (constant 2005 US$) of 1963 in Korea (Republic) to that in Mauritania?
Your answer should be very brief. 23.84. What is the ratio of the Value added (constant 2005 US$) in 1960 in Korea (Republic) to that in Pakistan?
Keep it short and to the point. 2.08. What is the ratio of the Value added (constant 2005 US$) of 1961 in Korea (Republic) to that in Pakistan?
Your response must be concise. 2.35. What is the ratio of the Value added (constant 2005 US$) in 1962 in Korea (Republic) to that in Pakistan?
Keep it short and to the point. 2.08. What is the ratio of the Value added (constant 2005 US$) in 1963 in Korea (Republic) to that in Pakistan?
Offer a very short reply. 2.17. What is the ratio of the Value added (constant 2005 US$) of 1960 in Mauritania to that in Pakistan?
Your answer should be compact. 0.11. What is the ratio of the Value added (constant 2005 US$) in 1961 in Mauritania to that in Pakistan?
Make the answer very short. 0.1. What is the ratio of the Value added (constant 2005 US$) in 1962 in Mauritania to that in Pakistan?
Give a very brief answer. 0.1. What is the ratio of the Value added (constant 2005 US$) of 1963 in Mauritania to that in Pakistan?
Offer a terse response. 0.09. What is the difference between the highest and the second highest Value added (constant 2005 US$) in 1960?
Offer a very short reply. 3.84e+1. What is the difference between the highest and the second highest Value added (constant 2005 US$) of 1961?
Provide a short and direct response. 3.74e+1. What is the difference between the highest and the second highest Value added (constant 2005 US$) in 1962?
Your answer should be compact. 3.71e+1. What is the difference between the highest and the second highest Value added (constant 2005 US$) in 1963?
Make the answer very short. 3.73e+1. What is the difference between the highest and the lowest Value added (constant 2005 US$) of 1960?
Keep it short and to the point. 4.69e+1. What is the difference between the highest and the lowest Value added (constant 2005 US$) of 1961?
Provide a short and direct response. 4.70e+1. What is the difference between the highest and the lowest Value added (constant 2005 US$) in 1962?
Your answer should be compact. 4.60e+1. What is the difference between the highest and the lowest Value added (constant 2005 US$) of 1963?
Ensure brevity in your answer.  4.71e+1. 